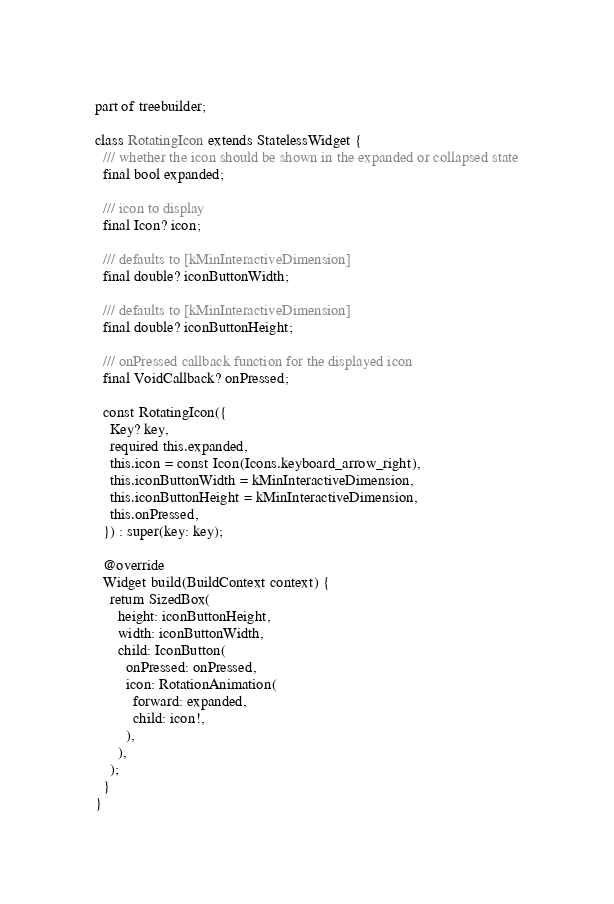<code> <loc_0><loc_0><loc_500><loc_500><_Dart_>part of treebuilder;

class RotatingIcon extends StatelessWidget {
  /// whether the icon should be shown in the expanded or collapsed state
  final bool expanded;

  /// icon to display
  final Icon? icon;

  /// defaults to [kMinInteractiveDimension]
  final double? iconButtonWidth;

  /// defaults to [kMinInteractiveDimension]
  final double? iconButtonHeight;

  /// onPressed callback function for the displayed icon
  final VoidCallback? onPressed;

  const RotatingIcon({
    Key? key,
    required this.expanded,
    this.icon = const Icon(Icons.keyboard_arrow_right),
    this.iconButtonWidth = kMinInteractiveDimension,
    this.iconButtonHeight = kMinInteractiveDimension,
    this.onPressed,
  }) : super(key: key);

  @override
  Widget build(BuildContext context) {
    return SizedBox(
      height: iconButtonHeight,
      width: iconButtonWidth,
      child: IconButton(
        onPressed: onPressed,
        icon: RotationAnimation(
          forward: expanded,
          child: icon!,
        ),
      ),
    );
  }
}
</code> 